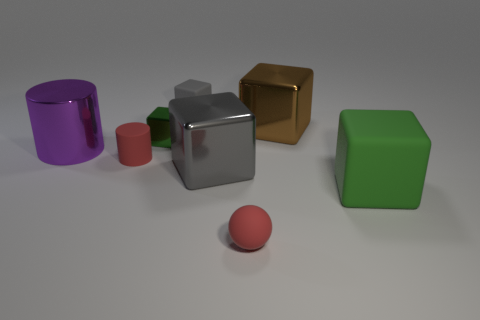Subtract all brown blocks. How many blocks are left? 4 Subtract all large green blocks. How many blocks are left? 4 Subtract all blue blocks. Subtract all brown balls. How many blocks are left? 5 Add 2 small green blocks. How many objects exist? 10 Subtract all cylinders. How many objects are left? 6 Add 6 small shiny blocks. How many small shiny blocks exist? 7 Subtract 0 cyan cylinders. How many objects are left? 8 Subtract all large yellow matte balls. Subtract all small green cubes. How many objects are left? 7 Add 6 red spheres. How many red spheres are left? 7 